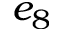<formula> <loc_0><loc_0><loc_500><loc_500>e _ { 8 }</formula> 